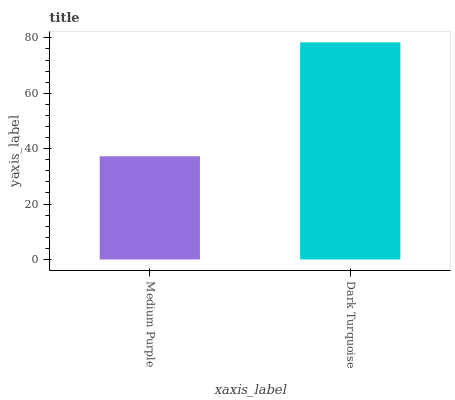Is Medium Purple the minimum?
Answer yes or no. Yes. Is Dark Turquoise the maximum?
Answer yes or no. Yes. Is Dark Turquoise the minimum?
Answer yes or no. No. Is Dark Turquoise greater than Medium Purple?
Answer yes or no. Yes. Is Medium Purple less than Dark Turquoise?
Answer yes or no. Yes. Is Medium Purple greater than Dark Turquoise?
Answer yes or no. No. Is Dark Turquoise less than Medium Purple?
Answer yes or no. No. Is Dark Turquoise the high median?
Answer yes or no. Yes. Is Medium Purple the low median?
Answer yes or no. Yes. Is Medium Purple the high median?
Answer yes or no. No. Is Dark Turquoise the low median?
Answer yes or no. No. 